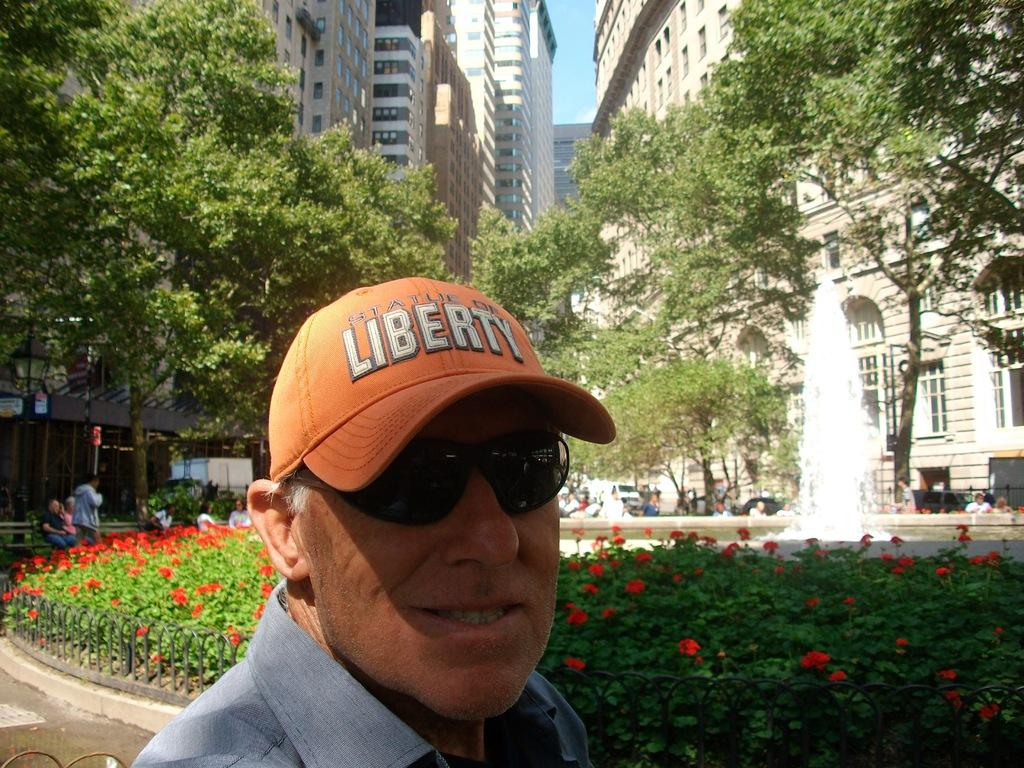Who is present in the image? There is a man in the image. What is the man doing in the image? The man is looking to his side. What is the man wearing in the image? The man is wearing a shirt, spectacles, and a cap. What type of vegetation can be seen in the image? There are flower plants and trees in the image. What type of structures are visible in the image? There are buildings visible at the top of the image. How many kittens are sitting on the man's lap in the image? There are no kittens present in the image. What type of lizards can be seen climbing the buildings in the image? There are no lizards visible in the image; only buildings are present at the top. 